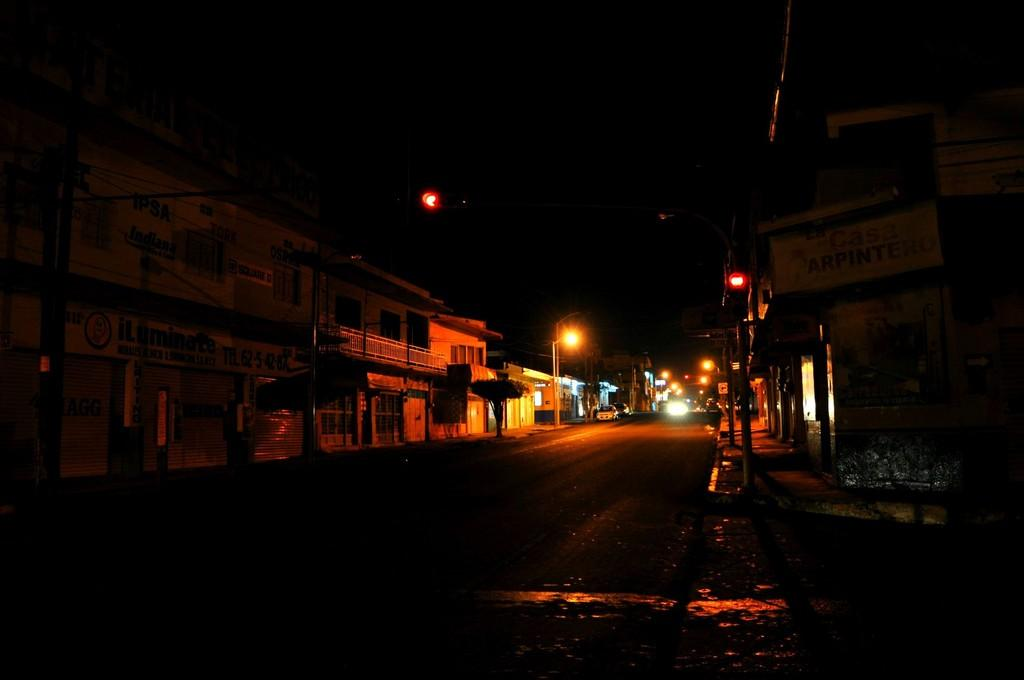What type of pathway is visible in the image? There is a road in the image. What objects can be seen in the image besides the road? There are boards, buildings, poles, lights, and vehicles visible in the image. What might be used to provide illumination in the image? The lights in the image might be used to provide illumination. What type of structures are present in the image? There are buildings in the image. What mode of transportation can be seen in the image? There are vehicles in the image. What type of curtain is hanging in the image? There is no curtain present in the image. What type of business is being conducted in the image? There is no indication of a business being conducted in the image. 